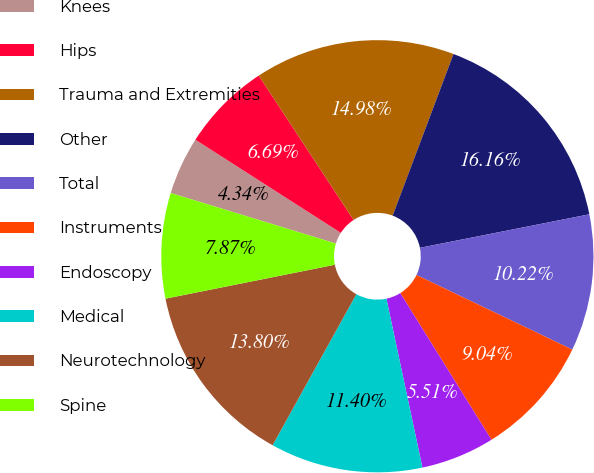Convert chart. <chart><loc_0><loc_0><loc_500><loc_500><pie_chart><fcel>Knees<fcel>Hips<fcel>Trauma and Extremities<fcel>Other<fcel>Total<fcel>Instruments<fcel>Endoscopy<fcel>Medical<fcel>Neurotechnology<fcel>Spine<nl><fcel>4.34%<fcel>6.69%<fcel>14.98%<fcel>16.16%<fcel>10.22%<fcel>9.04%<fcel>5.51%<fcel>11.4%<fcel>13.8%<fcel>7.87%<nl></chart> 